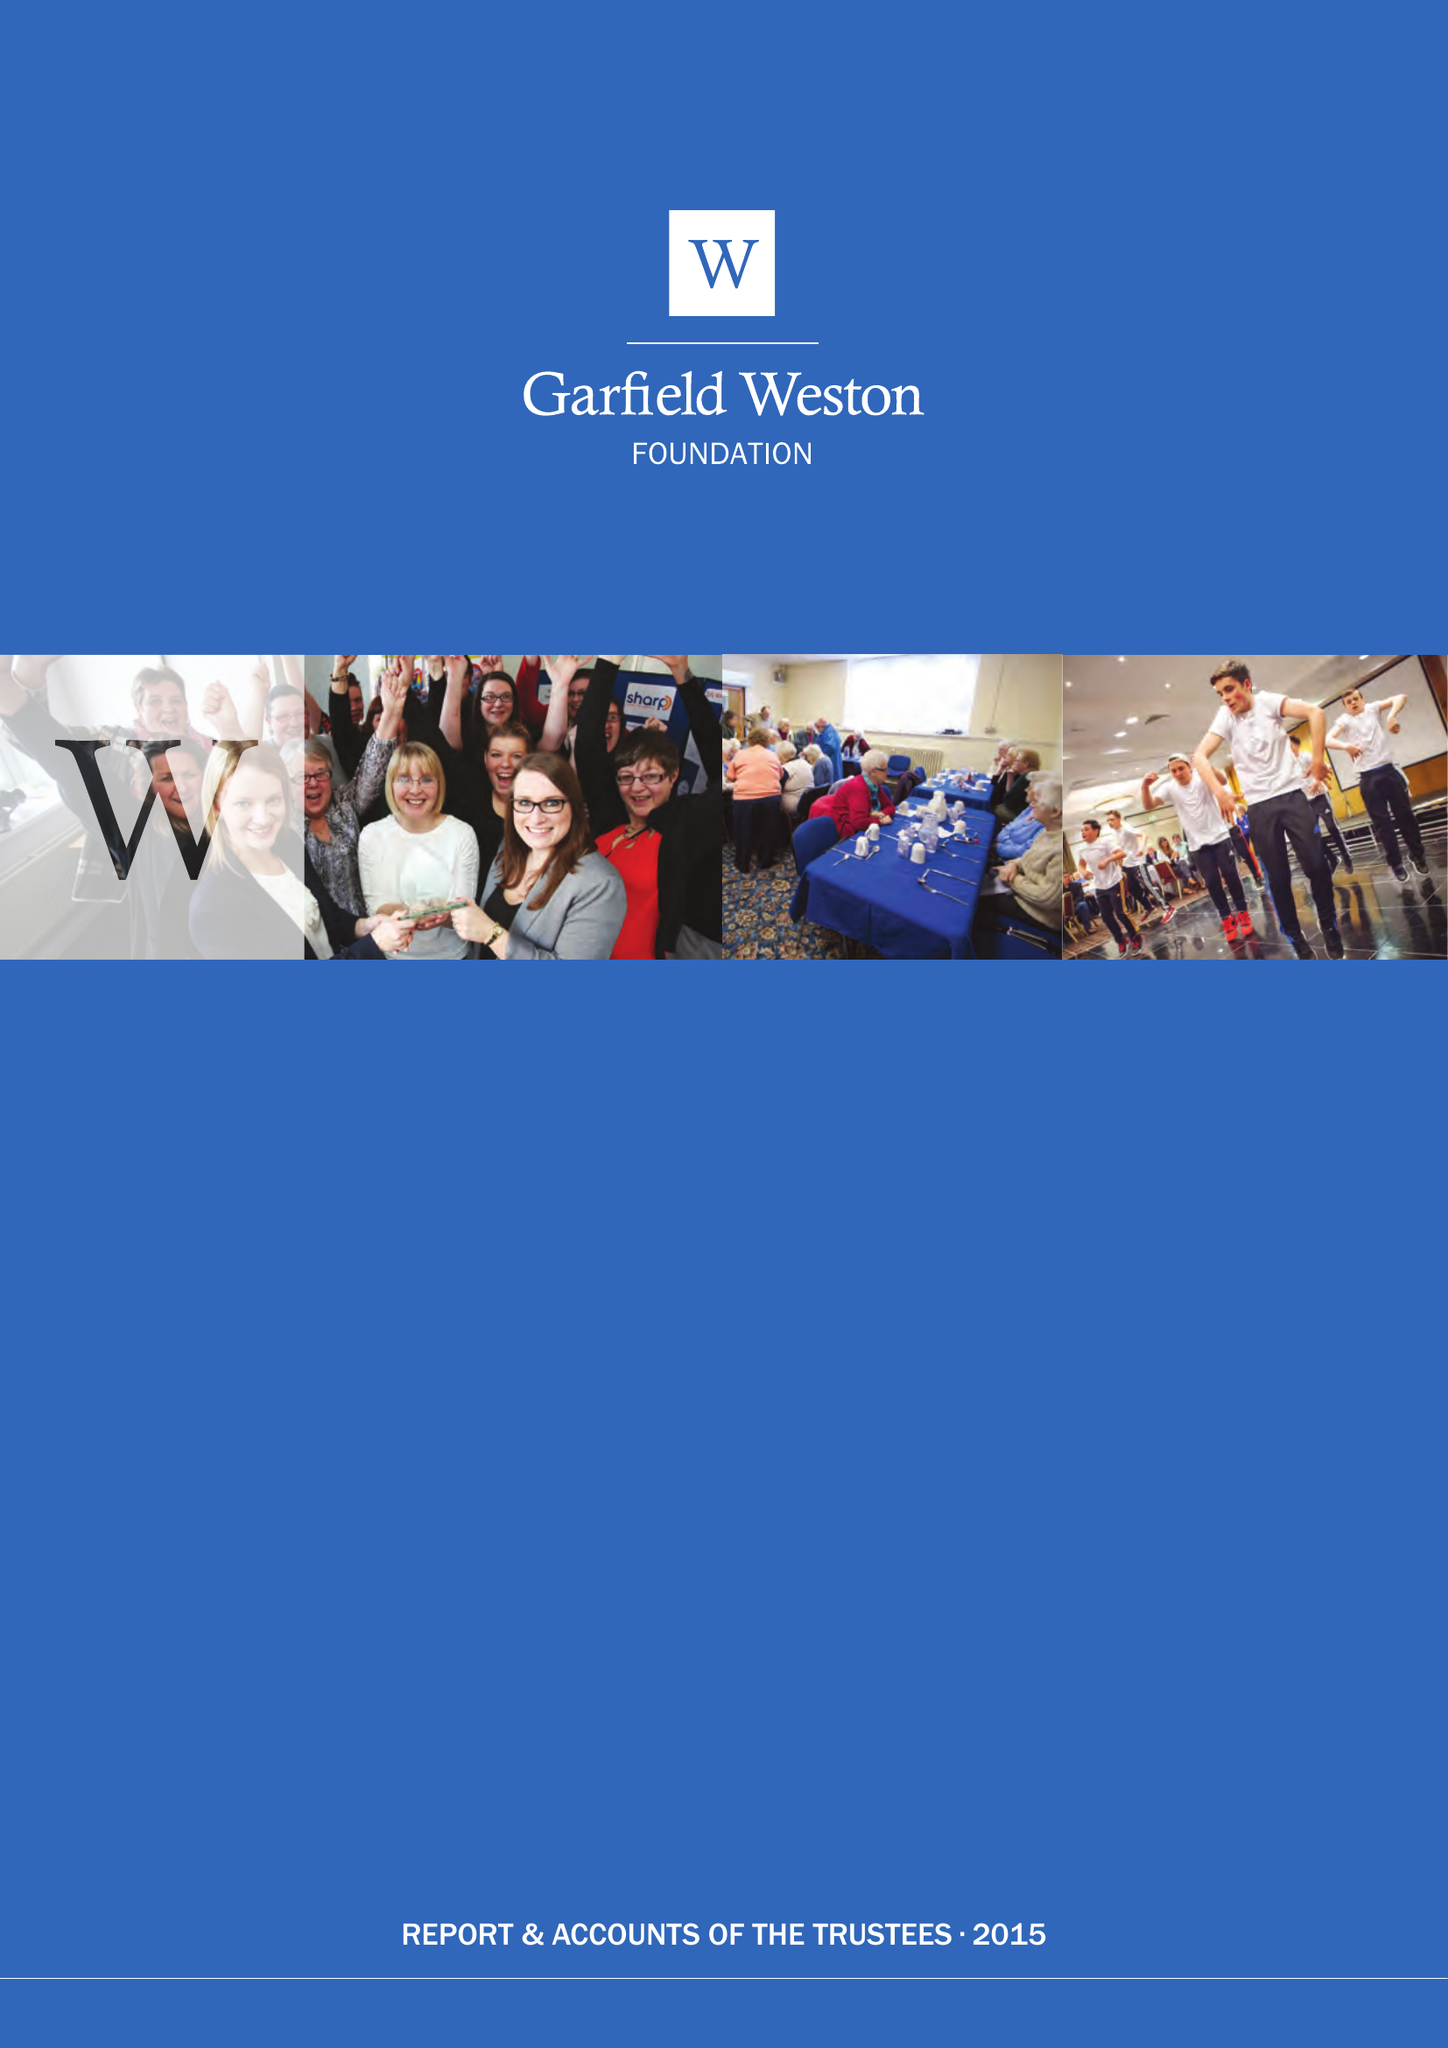What is the value for the charity_number?
Answer the question using a single word or phrase. 230260 